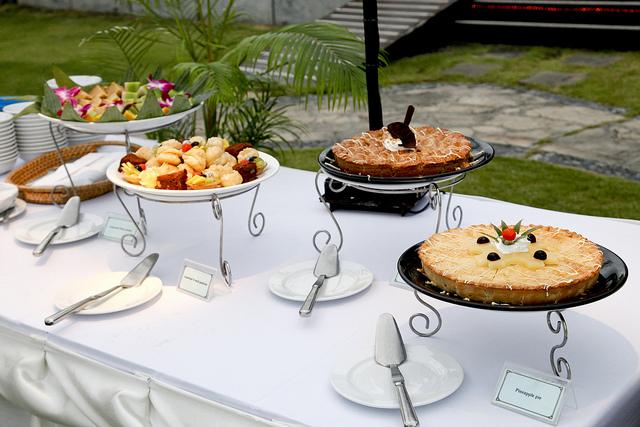How many pie cutter do you see?
Write a very short answer. 4. Are there knives?
Answer briefly. No. Are these food products protected from insects?
Write a very short answer. No. Is this event outside?
Be succinct. Yes. What color is the cake platter?
Quick response, please. Black. 